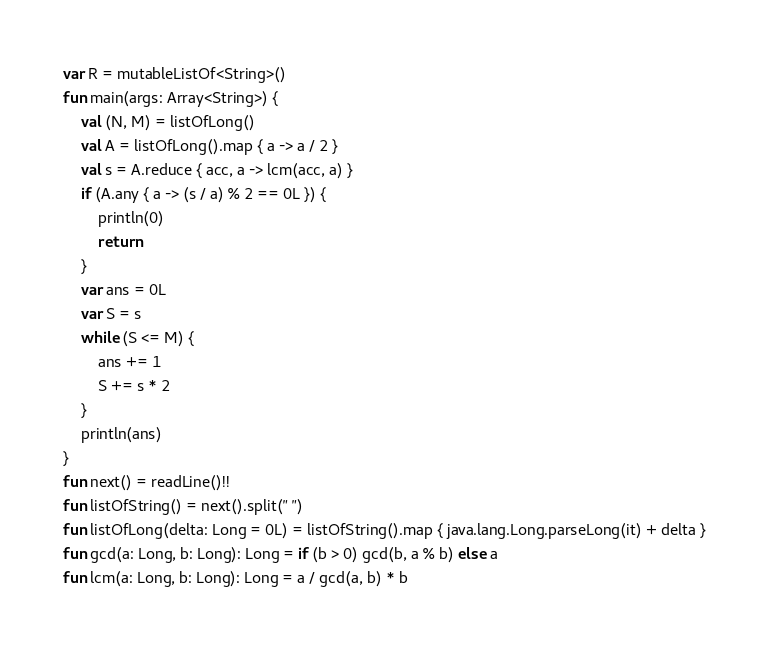Convert code to text. <code><loc_0><loc_0><loc_500><loc_500><_Kotlin_>var R = mutableListOf<String>()
fun main(args: Array<String>) {
    val (N, M) = listOfLong()
    val A = listOfLong().map { a -> a / 2 }
    val s = A.reduce { acc, a -> lcm(acc, a) }
    if (A.any { a -> (s / a) % 2 == 0L }) {
        println(0)
        return
    }
    var ans = 0L
    var S = s
    while (S <= M) {
        ans += 1
        S += s * 2
    }
    println(ans)
}
fun next() = readLine()!!
fun listOfString() = next().split(" ")
fun listOfLong(delta: Long = 0L) = listOfString().map { java.lang.Long.parseLong(it) + delta }
fun gcd(a: Long, b: Long): Long = if (b > 0) gcd(b, a % b) else a
fun lcm(a: Long, b: Long): Long = a / gcd(a, b) * b
</code> 